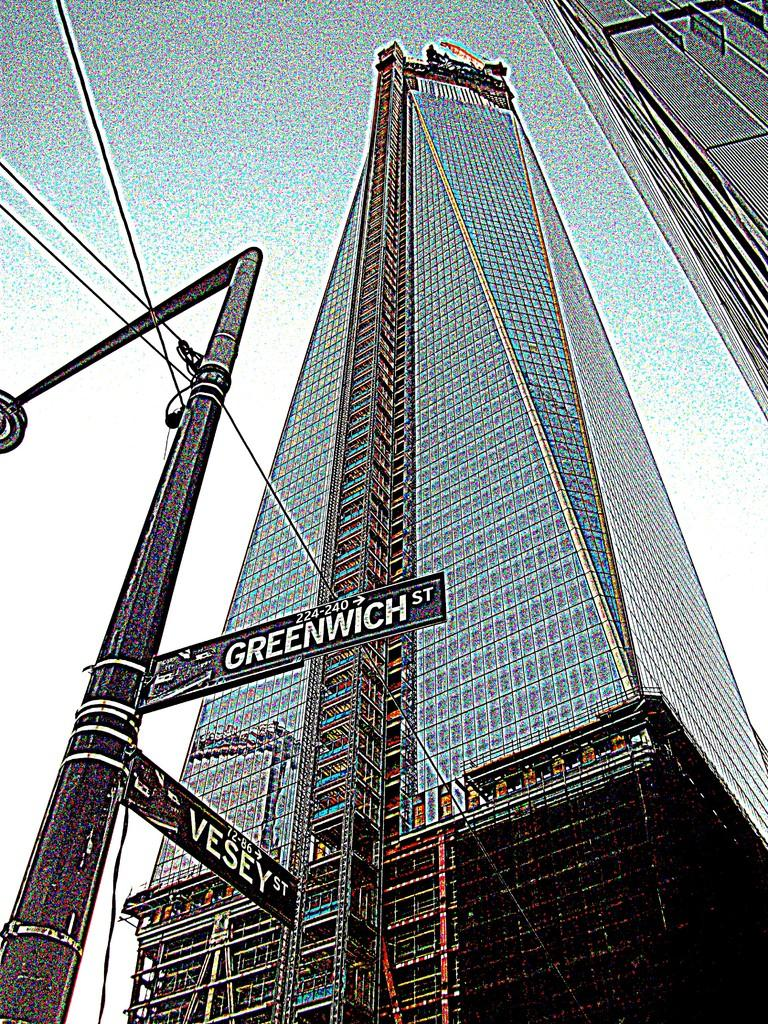What is located on the left side of the image? There is a street light on the left side of the image. What is attached to the street light? Boards are attached to the street light. What else can be seen connected to the street light? Wires are connected to the street light pole. What can be seen in the background of the image? There are buildings and the sky visible in the background of the image. What news is the kitty reading from its pocket in the image? There is no kitty or news present in the image; it features a street light with boards and wires. 